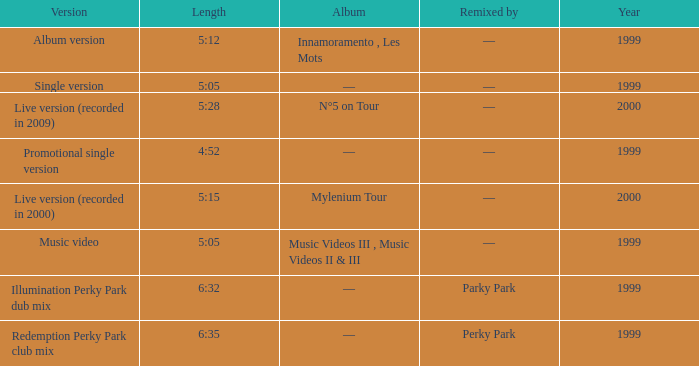What album is 5:15 long Live version (recorded in 2000). 